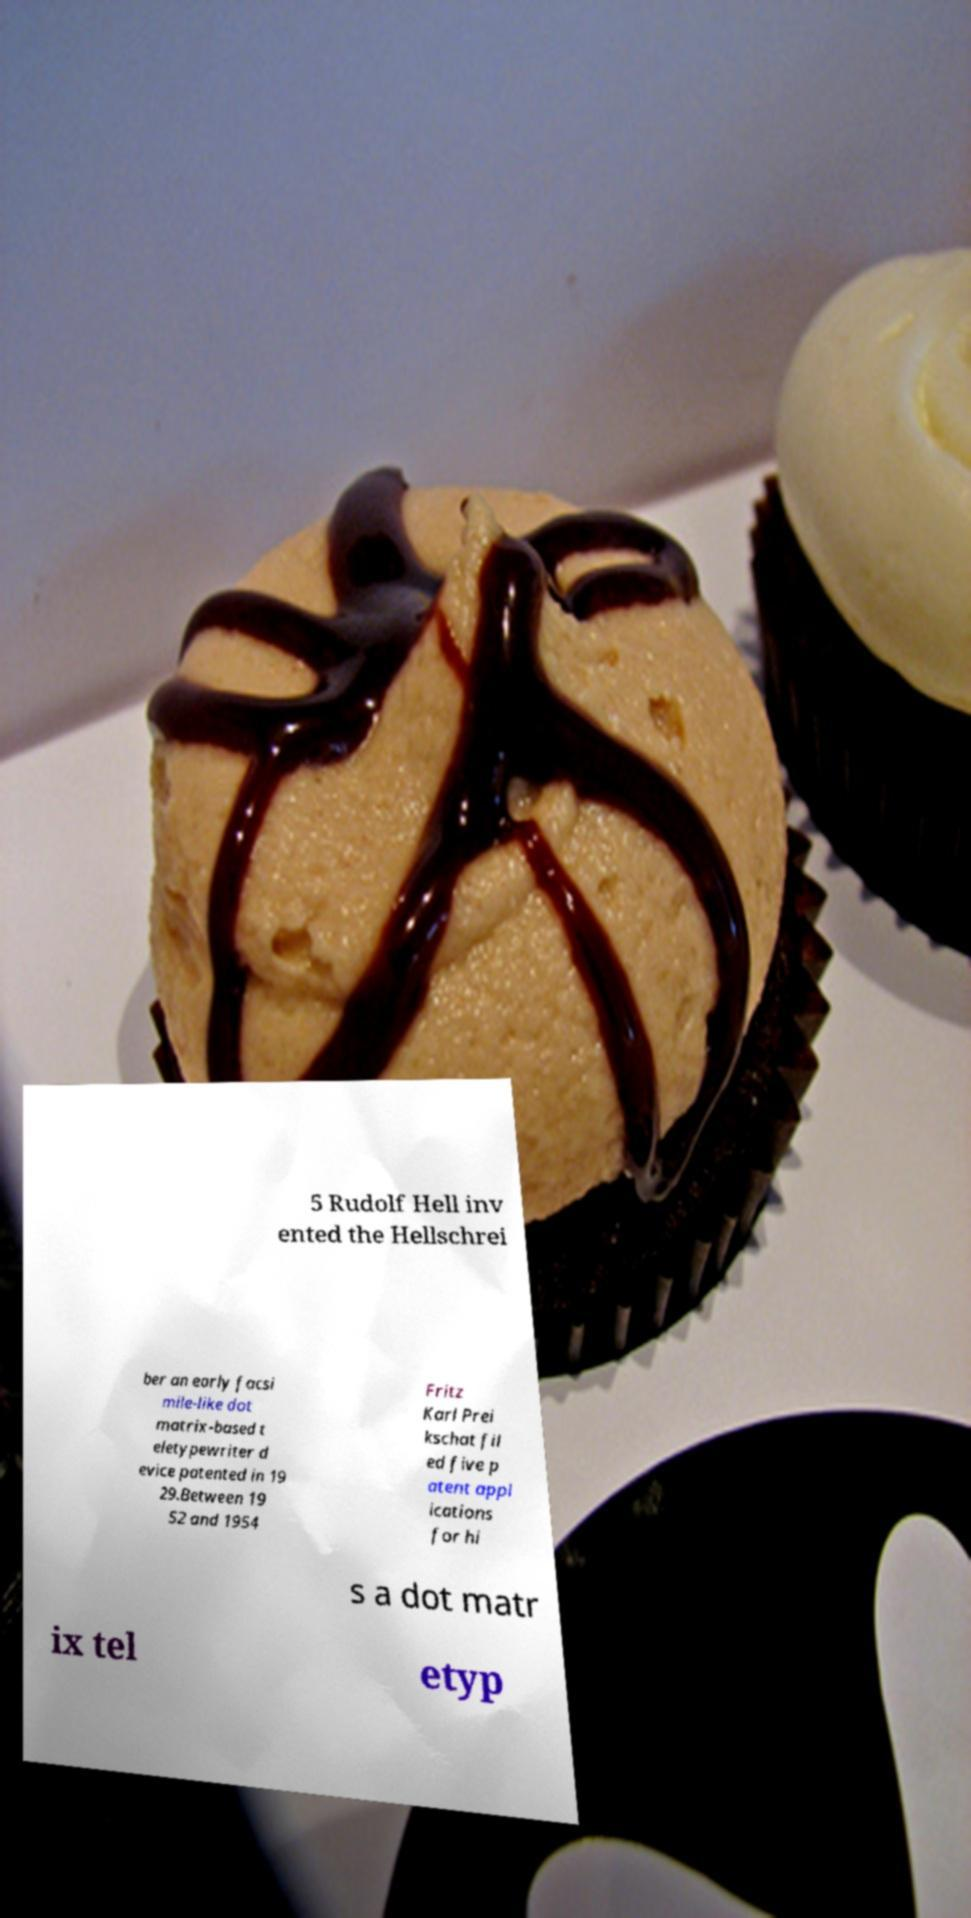There's text embedded in this image that I need extracted. Can you transcribe it verbatim? 5 Rudolf Hell inv ented the Hellschrei ber an early facsi mile-like dot matrix-based t eletypewriter d evice patented in 19 29.Between 19 52 and 1954 Fritz Karl Prei kschat fil ed five p atent appl ications for hi s a dot matr ix tel etyp 